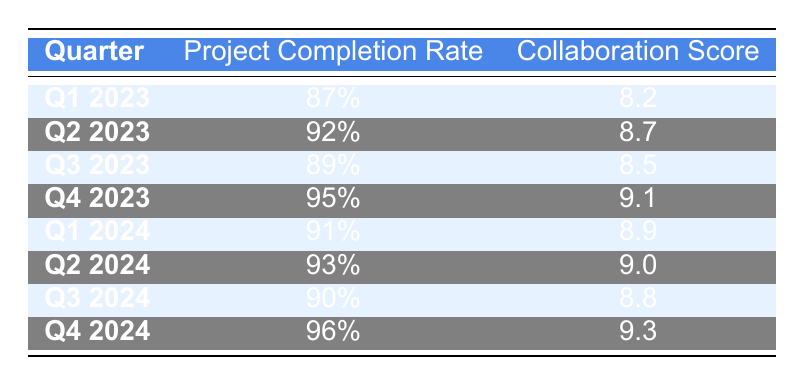What is the project completion rate for Q4 2023? The table specifies that for Q4 2023, the project completion rate is 95%. This information is directly retrievable from the corresponding row in the table.
Answer: 95% What is the collaboration score for Q2 2024? According to the table, the collaboration score for Q2 2024 is 9.0, which can be found in the relevant row of the table.
Answer: 9.0 Is the project completion rate in Q3 2024 higher than in Q1 2023? The project completion rate for Q3 2024 is 90% and for Q1 2023 it is 87%. Since 90% is greater than 87%, the answer is yes.
Answer: Yes What is the average collaboration score from Q1 2023 to Q4 2024? To find the average, we sum the collaboration scores: 8.2 + 8.7 + 8.5 + 9.1 + 8.9 + 9.0 + 8.8 + 9.3 = 70.5. Since there are 8 quarters, we divide 70.5 by 8, giving an average of 8.8125. Therefore, the average collaboration score is approximately 8.81 when rounded to two decimal places.
Answer: 8.81 What was the highest project completion rate, and in which quarter did it occur? The highest project completion rate in the table is 96%, which occurs in Q4 2024. This can be determined by comparing the project completion rates listed for all quarters.
Answer: 96% in Q4 2024 Was there any quarter where both the project completion rate and the collaboration score decreased from the previous quarter? By examining the table, we see that the project completion rate and collaboration score only decreased once: between Q2 2023 (92%) and Q3 2023 (89%), while the collaboration score decreased from 8.7 to 8.5 in the same period. Hence, this statement is true.
Answer: Yes What is the difference in collaboration scores between Q4 2023 and Q1 2024? The collaboration score for Q4 2023 is 9.1, and for Q1 2024 it is 8.9. The difference is calculated by subtracting 8.9 from 9.1, giving us a difference of 0.2.
Answer: 0.2 How many quarters had a project completion rate greater than 90%? By scanning the table, we find that the quarters with a project completion rate greater than 90% are Q2 2023 (92%), Q4 2023 (95%), Q1 2024 (91%), Q2 2024 (93%), and Q4 2024 (96%). This totals to 5 quarters.
Answer: 5 What is the trend in project completion rates from Q1 2023 to Q4 2024? By analyzing the data, we observe that the project completion rates generally increased over the specified period. Starting at 87%, it peaked at 96% in Q4 2024, indicating a positive upward trend overall.
Answer: Upward trend 